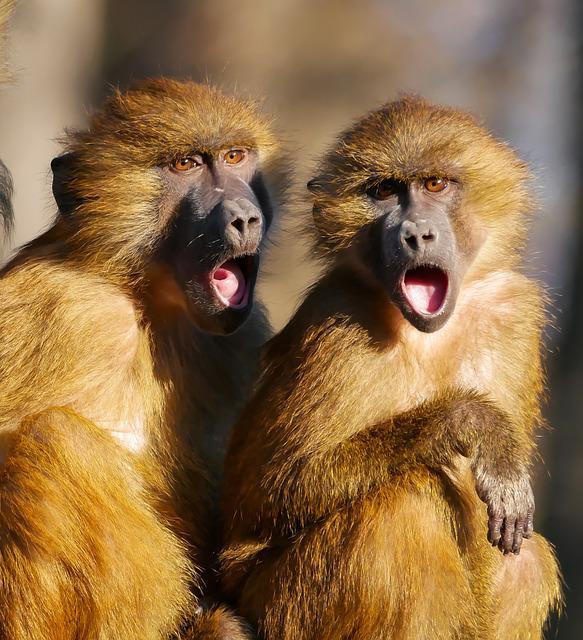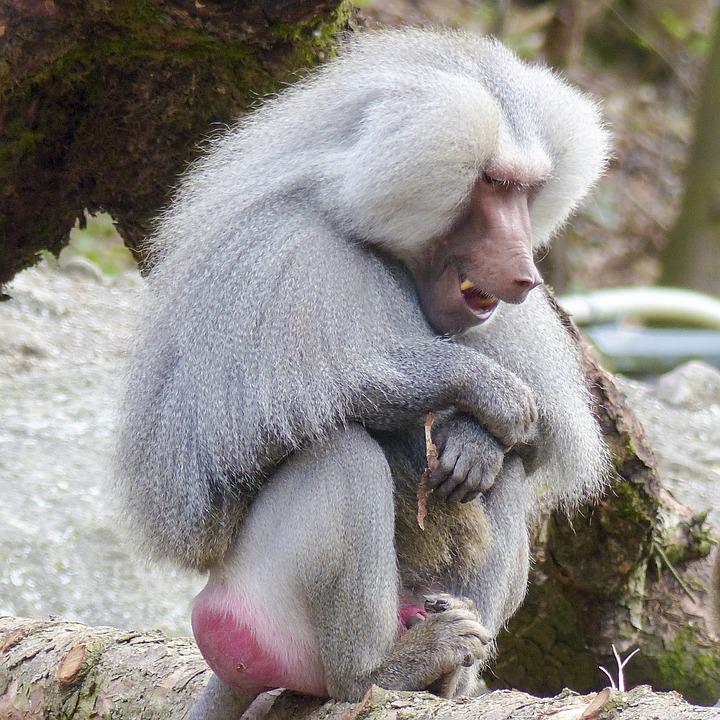The first image is the image on the left, the second image is the image on the right. Given the left and right images, does the statement "There are more primates in the image on the left." hold true? Answer yes or no. Yes. The first image is the image on the left, the second image is the image on the right. Considering the images on both sides, is "The right image shows a silvery long haired monkey sitting on its pink rear, and the left image shows two monkeys with matching coloring." valid? Answer yes or no. Yes. 